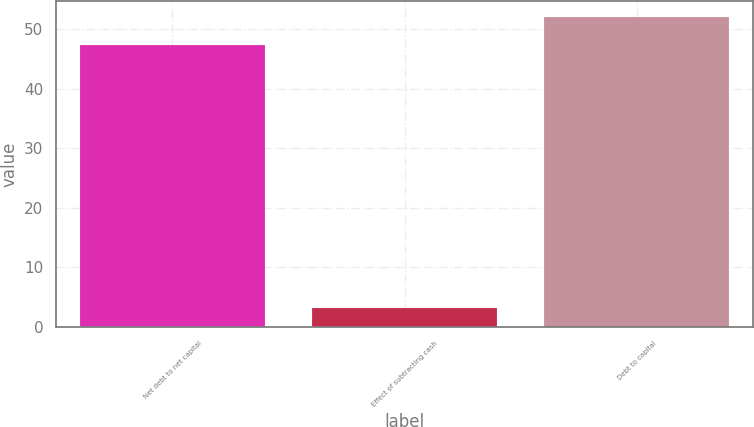Convert chart. <chart><loc_0><loc_0><loc_500><loc_500><bar_chart><fcel>Net debt to net capital<fcel>Effect of subtracting cash<fcel>Debt to capital<nl><fcel>47.4<fcel>3.2<fcel>52.14<nl></chart> 